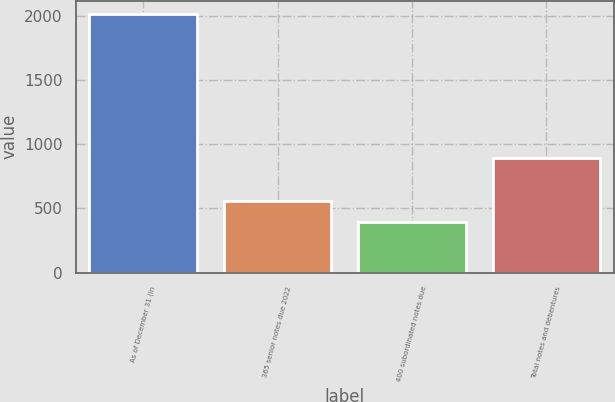Convert chart. <chart><loc_0><loc_0><loc_500><loc_500><bar_chart><fcel>As of December 31 (in<fcel>365 senior notes due 2022<fcel>400 subordinated notes due<fcel>Total notes and debentures<nl><fcel>2018<fcel>560.09<fcel>398.1<fcel>895.8<nl></chart> 